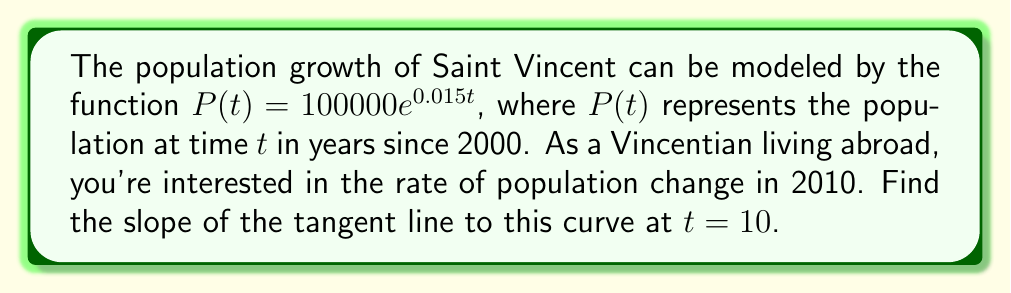Provide a solution to this math problem. To find the slope of the tangent line, we need to calculate the derivative of $P(t)$ and evaluate it at $t = 10$.

Step 1: Find the derivative of $P(t)$.
$$\frac{d}{dt}P(t) = \frac{d}{dt}(100000e^{0.015t})$$
Using the chain rule:
$$P'(t) = 100000 \cdot 0.015e^{0.015t}$$
$$P'(t) = 1500e^{0.015t}$$

Step 2: Evaluate $P'(t)$ at $t = 10$.
$$P'(10) = 1500e^{0.015 \cdot 10}$$
$$P'(10) = 1500e^{0.15}$$
$$P'(10) = 1500 \cdot 1.1618...$$
$$P'(10) \approx 1742.7$$

The slope of the tangent line at $t = 10$ is approximately 1742.7.

This means that in 2010, the population of Saint Vincent was growing at a rate of about 1743 people per year.
Answer: $1742.7$ people/year 